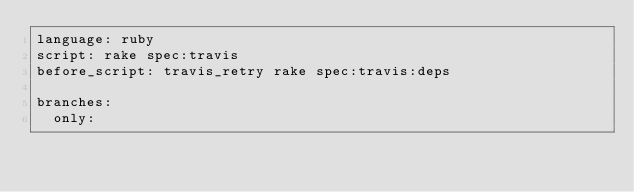<code> <loc_0><loc_0><loc_500><loc_500><_YAML_>language: ruby
script: rake spec:travis
before_script: travis_retry rake spec:travis:deps

branches:
  only:</code> 